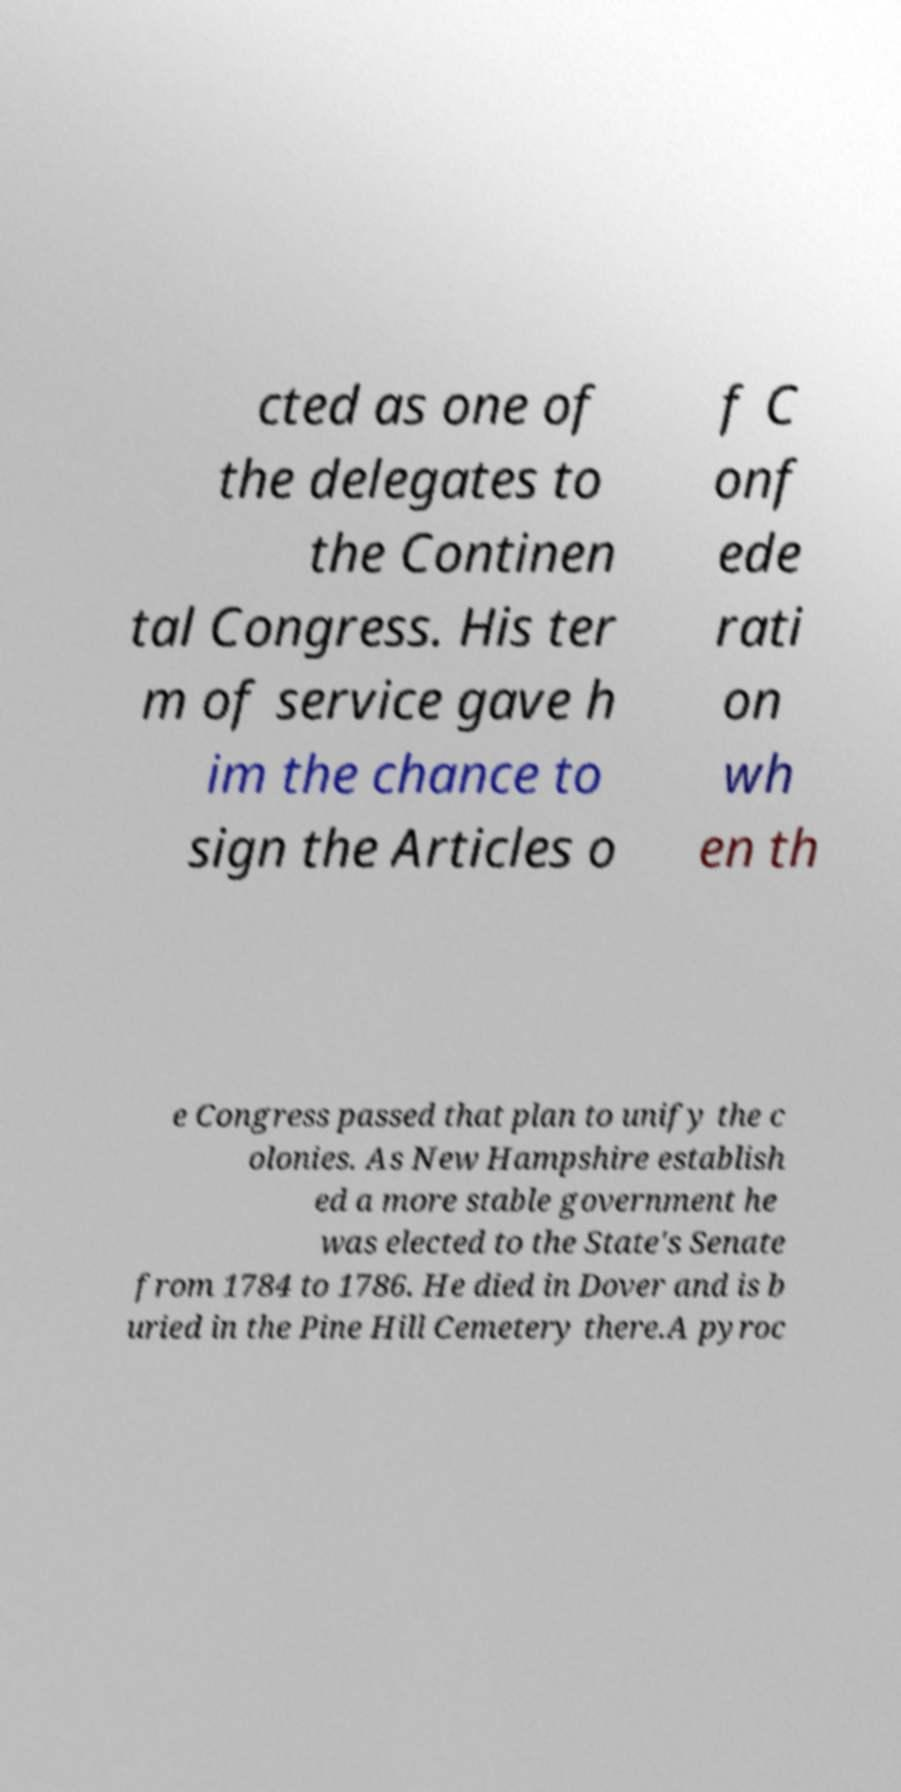For documentation purposes, I need the text within this image transcribed. Could you provide that? cted as one of the delegates to the Continen tal Congress. His ter m of service gave h im the chance to sign the Articles o f C onf ede rati on wh en th e Congress passed that plan to unify the c olonies. As New Hampshire establish ed a more stable government he was elected to the State's Senate from 1784 to 1786. He died in Dover and is b uried in the Pine Hill Cemetery there.A pyroc 